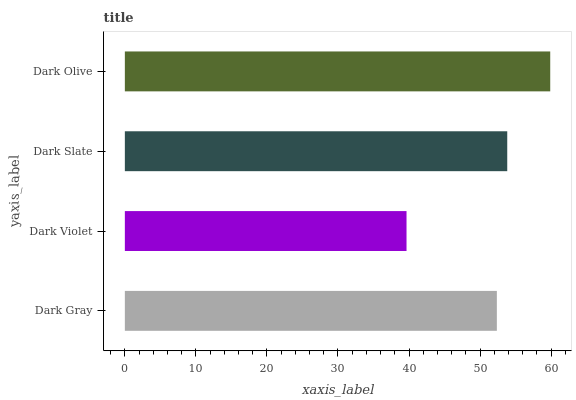Is Dark Violet the minimum?
Answer yes or no. Yes. Is Dark Olive the maximum?
Answer yes or no. Yes. Is Dark Slate the minimum?
Answer yes or no. No. Is Dark Slate the maximum?
Answer yes or no. No. Is Dark Slate greater than Dark Violet?
Answer yes or no. Yes. Is Dark Violet less than Dark Slate?
Answer yes or no. Yes. Is Dark Violet greater than Dark Slate?
Answer yes or no. No. Is Dark Slate less than Dark Violet?
Answer yes or no. No. Is Dark Slate the high median?
Answer yes or no. Yes. Is Dark Gray the low median?
Answer yes or no. Yes. Is Dark Violet the high median?
Answer yes or no. No. Is Dark Olive the low median?
Answer yes or no. No. 